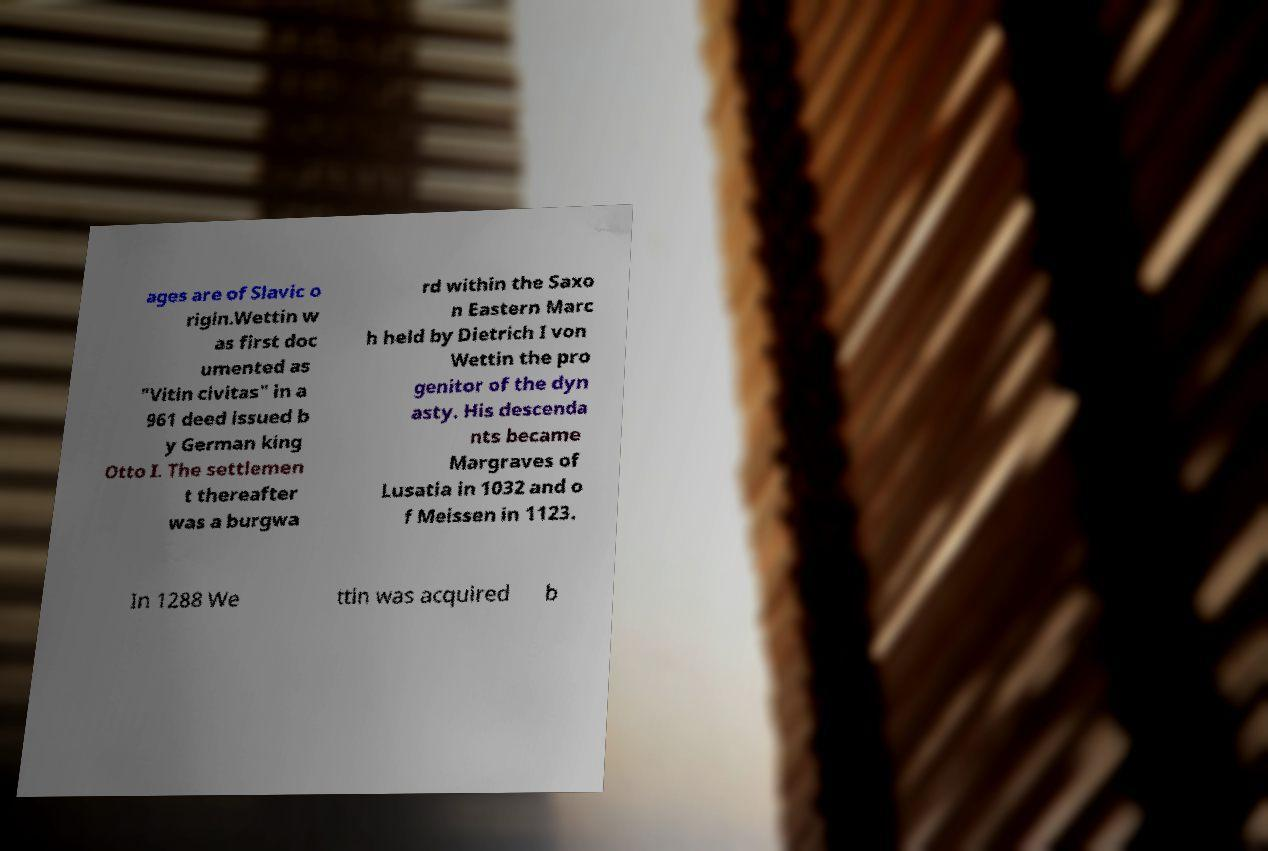There's text embedded in this image that I need extracted. Can you transcribe it verbatim? ages are of Slavic o rigin.Wettin w as first doc umented as "Vitin civitas" in a 961 deed issued b y German king Otto I. The settlemen t thereafter was a burgwa rd within the Saxo n Eastern Marc h held by Dietrich I von Wettin the pro genitor of the dyn asty. His descenda nts became Margraves of Lusatia in 1032 and o f Meissen in 1123. In 1288 We ttin was acquired b 